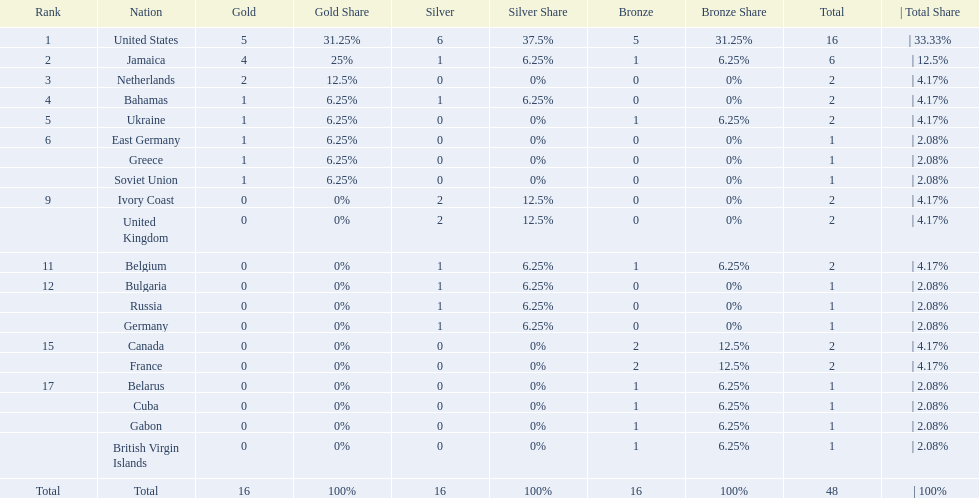How many nations won no gold medals? 12. 